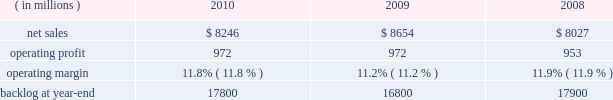Operating profit for the segment decreased by 1% ( 1 % ) in 2010 compared to 2009 .
For the year , operating profit declines in defense more than offset an increase in civil , while operating profit at intelligence essentially was unchanged .
The $ 27 million decrease in operating profit at defense primarily was attributable to a decrease in the level of favorable performance adjustments on mission and combat systems activities in 2010 .
The $ 19 million increase in civil principally was due to higher volume on enterprise civilian services .
Operating profit for the segment decreased by 3% ( 3 % ) in 2009 compared to 2008 .
Operating profit declines in civil and intelligence partially were offset by growth in defense .
The decrease of $ 29 million in civil 2019s operating profit primarily was attributable to a reduction in the level of favorable performance adjustments on enterprise civilian services programs in 2009 compared to 2008 .
The decrease in operating profit of $ 27 million at intelligence mainly was due to a reduction in the level of favorable performance adjustments on security solution activities in 2009 compared to 2008 .
The increase in defense 2019s operating profit of $ 29 million mainly was due to volume and improved performance in mission and combat systems .
The decrease in backlog during 2010 compared to 2009 mainly was due to higher sales volume on enterprise civilian service programs at civil , including volume associated with the dris 2010 program , and mission and combat system programs at defense .
Backlog decreased in 2009 compared to 2008 due to u.s .
Government 2019s exercise of the termination for convenience clause on the tsat mission operations system ( tmos ) contract at defense , which resulted in a $ 1.6 billion reduction in orders .
This decline more than offset increased orders on enterprise civilian services programs at civil .
We expect is&gs will experience a low single digit percentage decrease in sales for 2011 as compared to 2010 .
This decline primarily is due to completion of most of the work associated with the dris 2010 program .
Operating profit in 2011 is expected to decline in relationship to the decline in sales volume , while operating margins are expected to be comparable between the years .
Space systems our space systems business segment is engaged in the design , research and development , engineering , and production of satellites , strategic and defensive missile systems , and space transportation systems , including activities related to the planned replacement of the space shuttle .
Government satellite programs include the advanced extremely high frequency ( aehf ) system , the mobile user objective system ( muos ) , the global positioning satellite iii ( gps iii ) system , the space-based infrared system ( sbirs ) , and the geostationary operational environmental satellite r-series ( goes-r ) .
Strategic and missile defense programs include the targets and countermeasures program and the fleet ballistic missile program .
Space transportation includes the nasa orion program and , through ownership interests in two joint ventures , expendable launch services ( united launch alliance , or ula ) and space shuttle processing activities for the u.s .
Government ( united space alliance , or usa ) .
The space shuttle is expected to complete its final flight mission in 2011 and our involvement with its launch and processing activities will end at that time .
Space systems 2019 operating results included the following : ( in millions ) 2010 2009 2008 .
Net sales for space systems decreased by 5% ( 5 % ) in 2010 compared to 2009 .
Sales declined in all three lines of business during the year .
The $ 253 million decrease in space transportation principally was due to lower volume on the space shuttle external tank , commercial launch vehicle activity and other human space flight programs , which partially were offset by higher volume on the orion program .
There were no commercial launches in 2010 compared to one commercial launch in 2009 .
Strategic & defensive missile systems ( s&dms ) sales declined $ 147 million principally due to lower volume on defensive missile programs .
The $ 8 million sales decline in satellites primarily was attributable to lower volume on commercial satellites , which partially were offset by higher volume on government satellite activities .
There was one commercial satellite delivery in 2010 and one commercial satellite delivery in 2009 .
Net sales for space systems increased 8% ( 8 % ) in 2009 compared to 2008 .
During the year , sales growth at satellites and space transportation offset a decline in s&dms .
The sales growth of $ 707 million in satellites was due to higher volume in government satellite activities , which partially was offset by lower volume in commercial satellite activities .
There was one commercial satellite delivery in 2009 and two deliveries in 2008 .
The increase in sales of $ 21 million in space transportation primarily was due to higher volume on the orion program , which more than offset a decline in the space shuttle 2019s external tank program .
There was one commercial launch in both 2009 and 2008 .
S&dms 2019 sales decreased by $ 102 million mainly due to lower volume on defensive missile programs , which more than offset growth in strategic missile programs. .
What were average operating profit for space systems in millions from 2008 to 2010? 
Computations: table_average(operating profit, none)
Answer: 965.66667. 